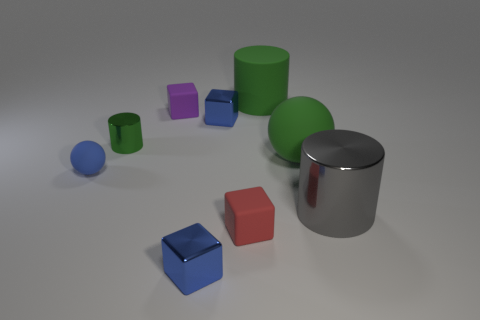Subtract all blocks. How many objects are left? 5 Add 5 large green cylinders. How many large green cylinders exist? 6 Subtract 0 blue cylinders. How many objects are left? 9 Subtract all big red matte objects. Subtract all large matte cylinders. How many objects are left? 8 Add 2 tiny green metal objects. How many tiny green metal objects are left? 3 